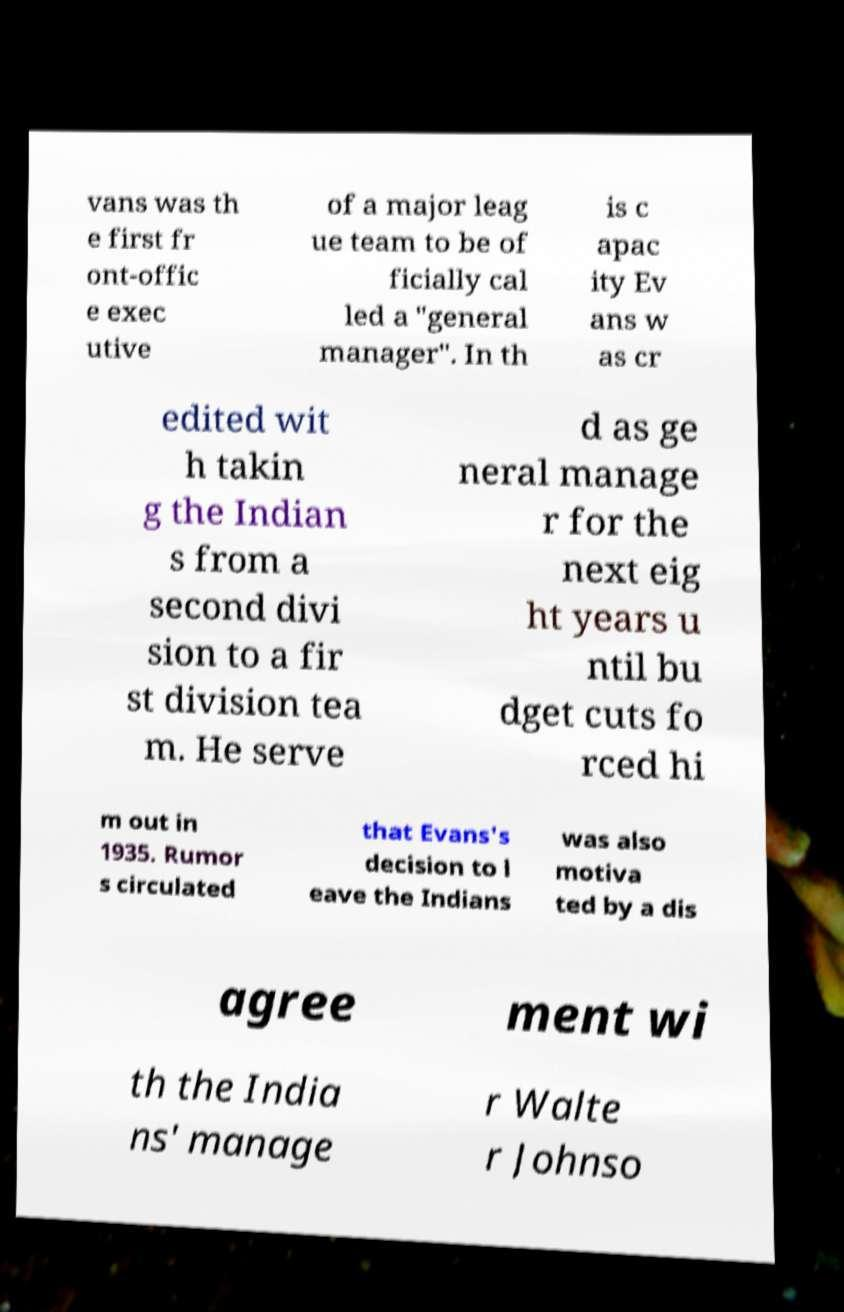I need the written content from this picture converted into text. Can you do that? vans was th e first fr ont-offic e exec utive of a major leag ue team to be of ficially cal led a "general manager". In th is c apac ity Ev ans w as cr edited wit h takin g the Indian s from a second divi sion to a fir st division tea m. He serve d as ge neral manage r for the next eig ht years u ntil bu dget cuts fo rced hi m out in 1935. Rumor s circulated that Evans's decision to l eave the Indians was also motiva ted by a dis agree ment wi th the India ns' manage r Walte r Johnso 